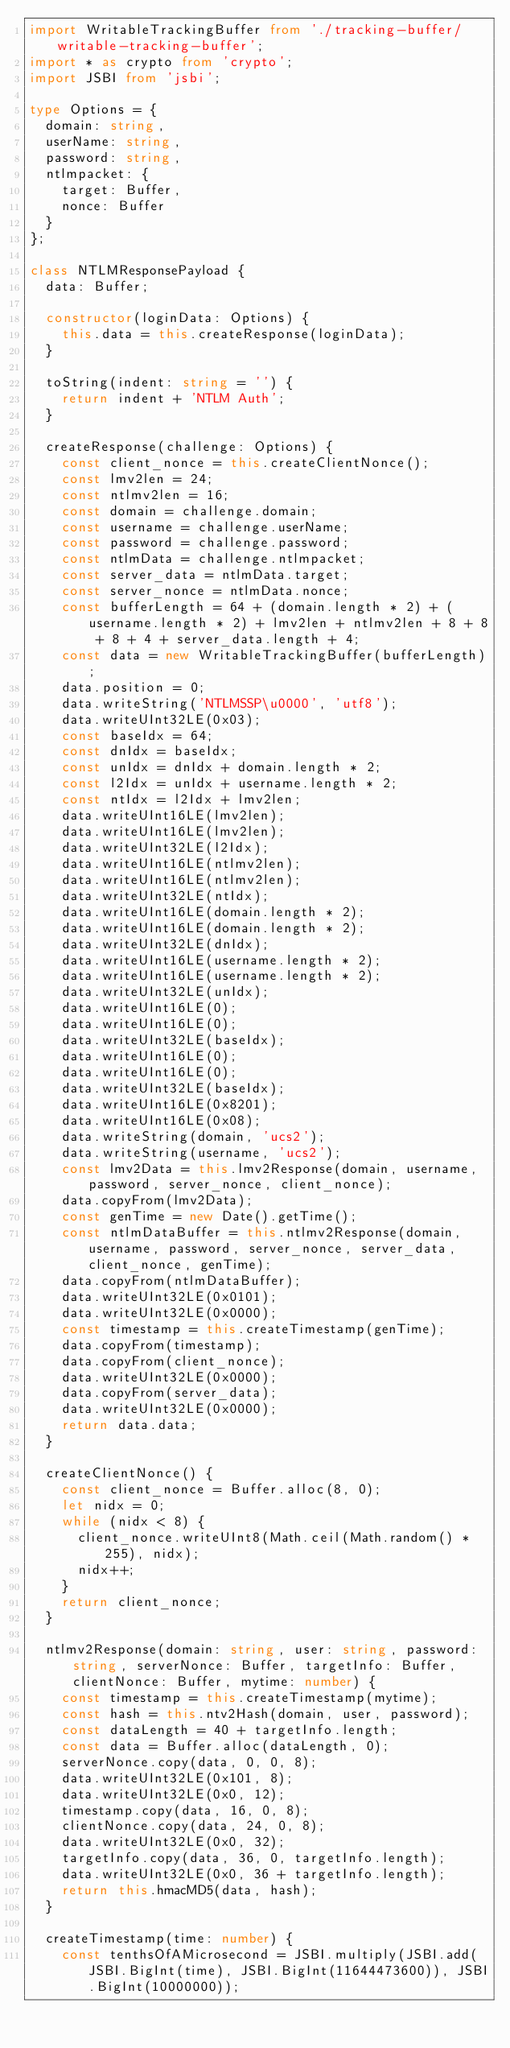Convert code to text. <code><loc_0><loc_0><loc_500><loc_500><_TypeScript_>import WritableTrackingBuffer from './tracking-buffer/writable-tracking-buffer';
import * as crypto from 'crypto';
import JSBI from 'jsbi';

type Options = {
  domain: string,
  userName: string,
  password: string,
  ntlmpacket: {
    target: Buffer,
    nonce: Buffer
  }
};

class NTLMResponsePayload {
  data: Buffer;

  constructor(loginData: Options) {
    this.data = this.createResponse(loginData);
  }

  toString(indent: string = '') {
    return indent + 'NTLM Auth';
  }

  createResponse(challenge: Options) {
    const client_nonce = this.createClientNonce();
    const lmv2len = 24;
    const ntlmv2len = 16;
    const domain = challenge.domain;
    const username = challenge.userName;
    const password = challenge.password;
    const ntlmData = challenge.ntlmpacket;
    const server_data = ntlmData.target;
    const server_nonce = ntlmData.nonce;
    const bufferLength = 64 + (domain.length * 2) + (username.length * 2) + lmv2len + ntlmv2len + 8 + 8 + 8 + 4 + server_data.length + 4;
    const data = new WritableTrackingBuffer(bufferLength);
    data.position = 0;
    data.writeString('NTLMSSP\u0000', 'utf8');
    data.writeUInt32LE(0x03);
    const baseIdx = 64;
    const dnIdx = baseIdx;
    const unIdx = dnIdx + domain.length * 2;
    const l2Idx = unIdx + username.length * 2;
    const ntIdx = l2Idx + lmv2len;
    data.writeUInt16LE(lmv2len);
    data.writeUInt16LE(lmv2len);
    data.writeUInt32LE(l2Idx);
    data.writeUInt16LE(ntlmv2len);
    data.writeUInt16LE(ntlmv2len);
    data.writeUInt32LE(ntIdx);
    data.writeUInt16LE(domain.length * 2);
    data.writeUInt16LE(domain.length * 2);
    data.writeUInt32LE(dnIdx);
    data.writeUInt16LE(username.length * 2);
    data.writeUInt16LE(username.length * 2);
    data.writeUInt32LE(unIdx);
    data.writeUInt16LE(0);
    data.writeUInt16LE(0);
    data.writeUInt32LE(baseIdx);
    data.writeUInt16LE(0);
    data.writeUInt16LE(0);
    data.writeUInt32LE(baseIdx);
    data.writeUInt16LE(0x8201);
    data.writeUInt16LE(0x08);
    data.writeString(domain, 'ucs2');
    data.writeString(username, 'ucs2');
    const lmv2Data = this.lmv2Response(domain, username, password, server_nonce, client_nonce);
    data.copyFrom(lmv2Data);
    const genTime = new Date().getTime();
    const ntlmDataBuffer = this.ntlmv2Response(domain, username, password, server_nonce, server_data, client_nonce, genTime);
    data.copyFrom(ntlmDataBuffer);
    data.writeUInt32LE(0x0101);
    data.writeUInt32LE(0x0000);
    const timestamp = this.createTimestamp(genTime);
    data.copyFrom(timestamp);
    data.copyFrom(client_nonce);
    data.writeUInt32LE(0x0000);
    data.copyFrom(server_data);
    data.writeUInt32LE(0x0000);
    return data.data;
  }

  createClientNonce() {
    const client_nonce = Buffer.alloc(8, 0);
    let nidx = 0;
    while (nidx < 8) {
      client_nonce.writeUInt8(Math.ceil(Math.random() * 255), nidx);
      nidx++;
    }
    return client_nonce;
  }

  ntlmv2Response(domain: string, user: string, password: string, serverNonce: Buffer, targetInfo: Buffer, clientNonce: Buffer, mytime: number) {
    const timestamp = this.createTimestamp(mytime);
    const hash = this.ntv2Hash(domain, user, password);
    const dataLength = 40 + targetInfo.length;
    const data = Buffer.alloc(dataLength, 0);
    serverNonce.copy(data, 0, 0, 8);
    data.writeUInt32LE(0x101, 8);
    data.writeUInt32LE(0x0, 12);
    timestamp.copy(data, 16, 0, 8);
    clientNonce.copy(data, 24, 0, 8);
    data.writeUInt32LE(0x0, 32);
    targetInfo.copy(data, 36, 0, targetInfo.length);
    data.writeUInt32LE(0x0, 36 + targetInfo.length);
    return this.hmacMD5(data, hash);
  }

  createTimestamp(time: number) {
    const tenthsOfAMicrosecond = JSBI.multiply(JSBI.add(JSBI.BigInt(time), JSBI.BigInt(11644473600)), JSBI.BigInt(10000000));
</code> 